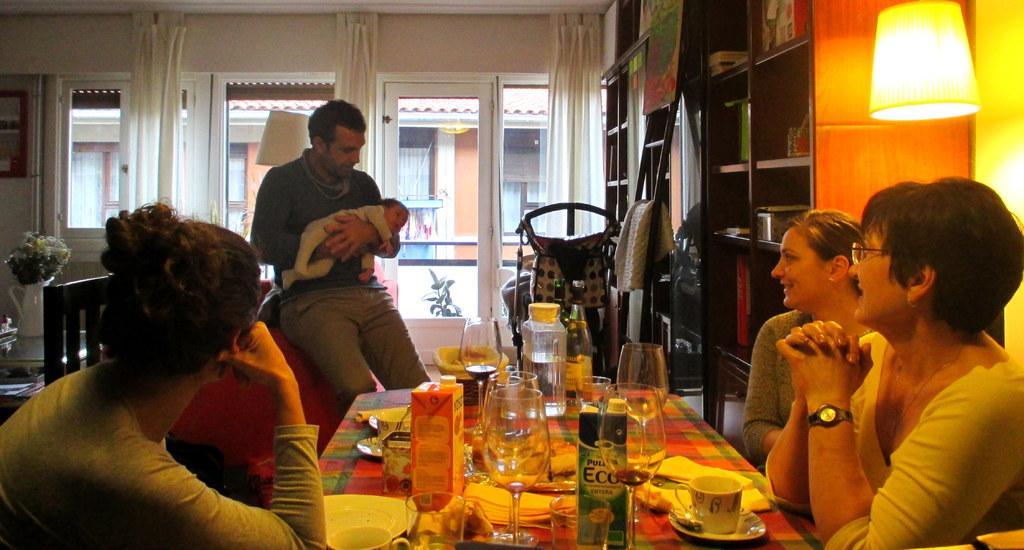Can you describe this image briefly? In this picture there are three women sitting on a chair. There is a man holding a baby. There is a glass, cup, saucer , box, bowl, bottle and few things on the table. There is a curtain. lamp, shelves, flower pot. There is a building. 